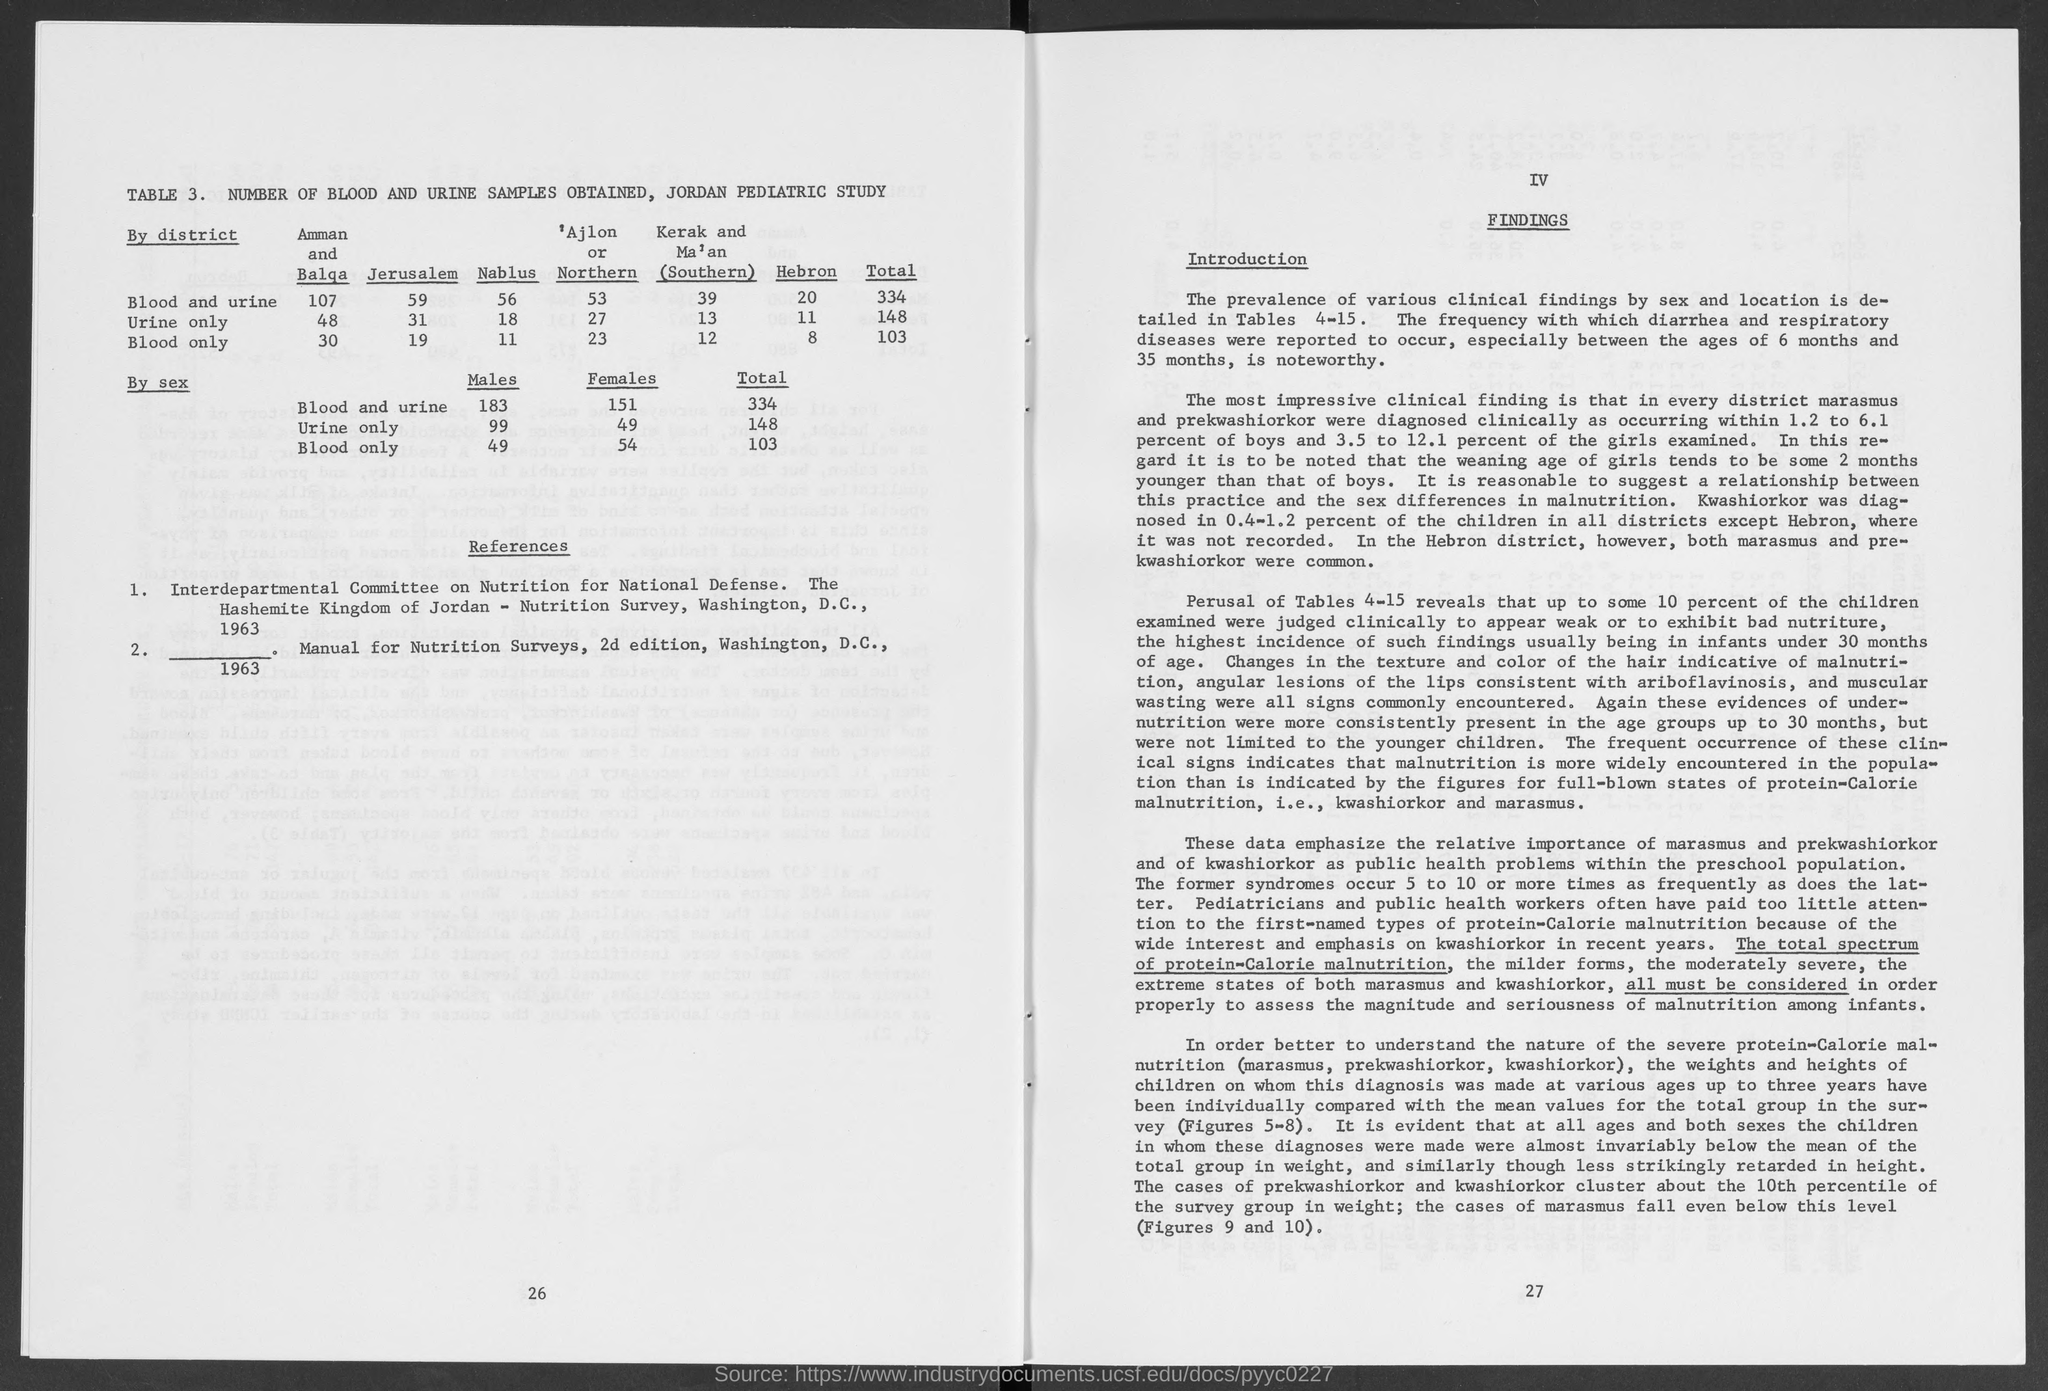What is the title of table 3.?
Provide a short and direct response. Number of Blood and Urine Samples obtained, Jordan Pediatric Study. 